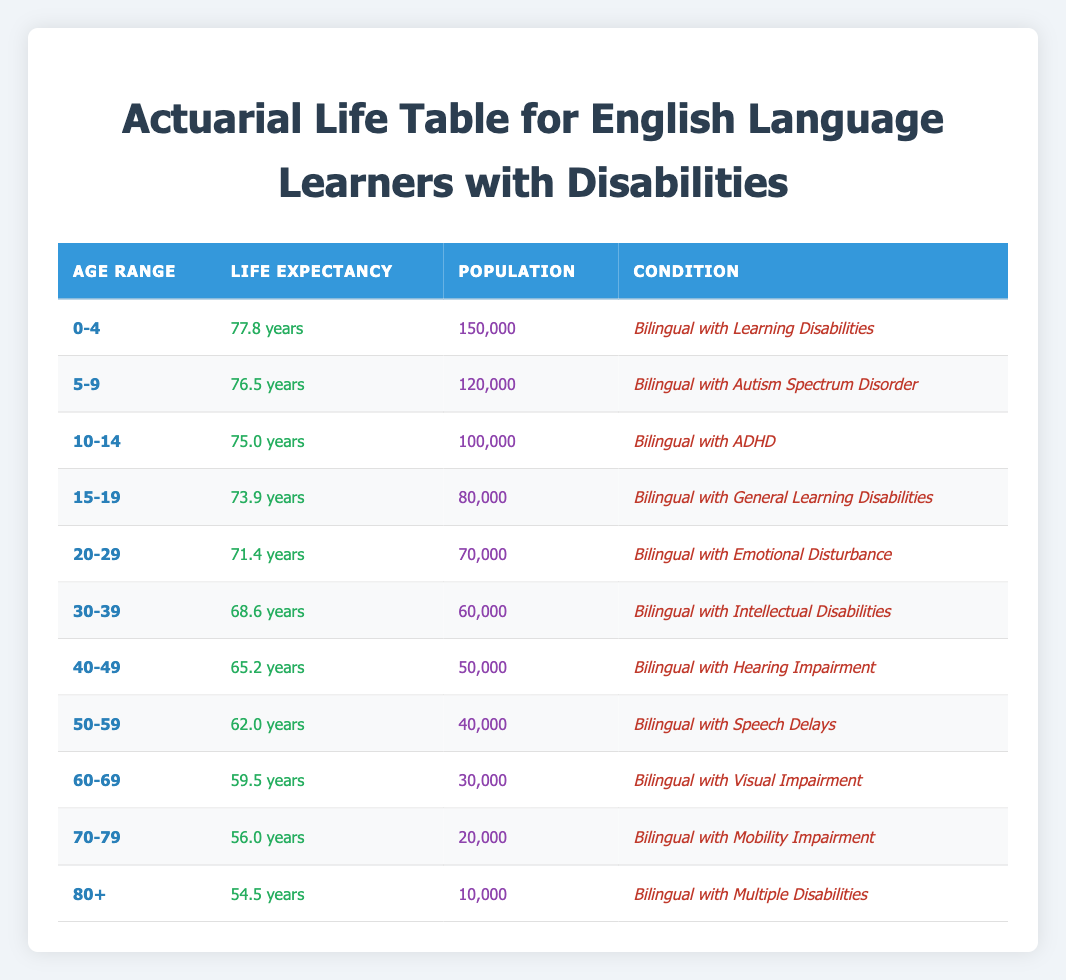What is the life expectancy for the age group 0-4? The life expectancy for the age range 0-4 is listed directly in the table under the "Life Expectancy" column, which states it is 77.8 years.
Answer: 77.8 years How many people are in the age group 50-59? According to the table, the population in the age range 50-59 is specified in the "Population" column as 40,000.
Answer: 40,000 What is the life expectancy difference between the 30-39 age group and the 20-29 age group? The life expectancy for the 30-39 age group is 68.6 years, and for the 20-29 age group, it is 71.4 years. The difference can be calculated as 71.4 - 68.6 = 2.8 years.
Answer: 2.8 years Is the life expectancy for individuals with Hearing Impairment higher than those with Emotional Disturbance? The life expectancy for Bilingual with Hearing Impairment is 65.2 years, while for Bilingual with Emotional Disturbance, it is 71.4 years. Since 65.2 is less than 71.4, the answer is no.
Answer: No What is the average life expectancy for age groups 40-49 and 60-69? The life expectancy for the 40-49 age group is 65.2 years, and for the 60-69 age group, it is 59.5 years. The average of these two groups is calculated as (65.2 + 59.5) / 2 = 62.35 years.
Answer: 62.35 years How many individuals are bilingual with learning disabilities under the age of 15? To find the number of bilingual with Learning Disabilities, we look at the population numbers for the 0-4 and 5-9 age groups. The total for these age groups is 150,000 (age 0-4) + 120,000 (age 5-9) = 270,000.
Answer: 270,000 Is there a gradual decline in life expectancy as age increases? Observing the life expectancy values from the table, we can see that as age increases from 0-4 to 80+, the life expectancy decreases. This pattern indicates a decline, affirming that the statement is true.
Answer: Yes What are the conditions for the age group 70-79? The table specifies that for the 70-79 age group, the condition listed is "Bilingual with Mobility Impairment." This can be directly referenced from the "Condition" column in the table.
Answer: Bilingual with Mobility Impairment 